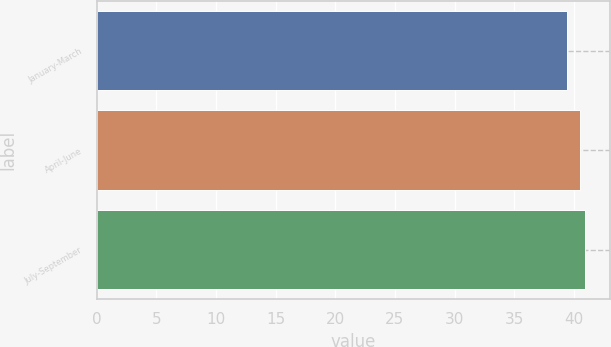Convert chart. <chart><loc_0><loc_0><loc_500><loc_500><bar_chart><fcel>January-March<fcel>April-June<fcel>July-September<nl><fcel>39.38<fcel>40.48<fcel>40.95<nl></chart> 